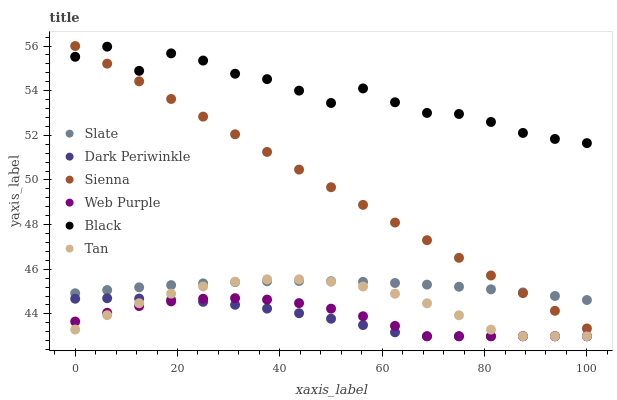Does Dark Periwinkle have the minimum area under the curve?
Answer yes or no. Yes. Does Black have the maximum area under the curve?
Answer yes or no. Yes. Does Sienna have the minimum area under the curve?
Answer yes or no. No. Does Sienna have the maximum area under the curve?
Answer yes or no. No. Is Sienna the smoothest?
Answer yes or no. Yes. Is Black the roughest?
Answer yes or no. Yes. Is Web Purple the smoothest?
Answer yes or no. No. Is Web Purple the roughest?
Answer yes or no. No. Does Web Purple have the lowest value?
Answer yes or no. Yes. Does Sienna have the lowest value?
Answer yes or no. No. Does Sienna have the highest value?
Answer yes or no. Yes. Does Web Purple have the highest value?
Answer yes or no. No. Is Web Purple less than Slate?
Answer yes or no. Yes. Is Black greater than Web Purple?
Answer yes or no. Yes. Does Dark Periwinkle intersect Tan?
Answer yes or no. Yes. Is Dark Periwinkle less than Tan?
Answer yes or no. No. Is Dark Periwinkle greater than Tan?
Answer yes or no. No. Does Web Purple intersect Slate?
Answer yes or no. No. 